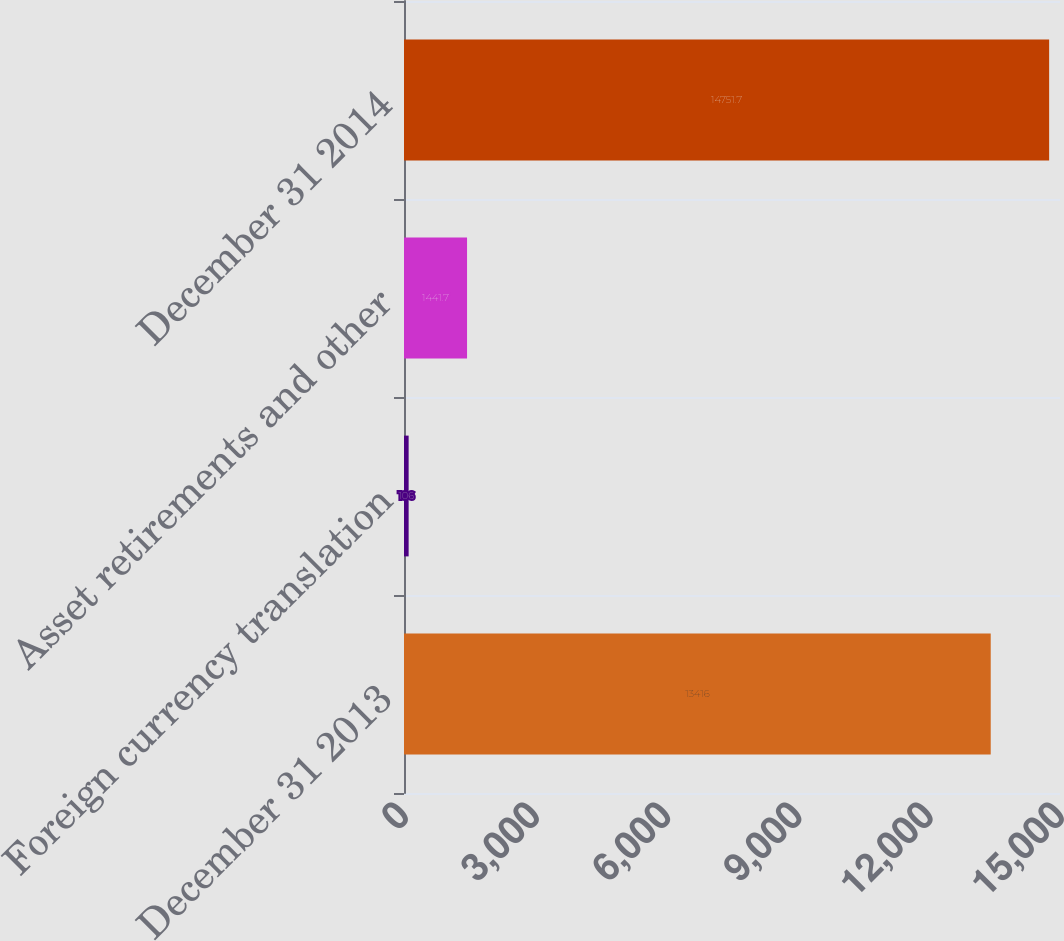<chart> <loc_0><loc_0><loc_500><loc_500><bar_chart><fcel>December 31 2013<fcel>Foreign currency translation<fcel>Asset retirements and other<fcel>December 31 2014<nl><fcel>13416<fcel>106<fcel>1441.7<fcel>14751.7<nl></chart> 